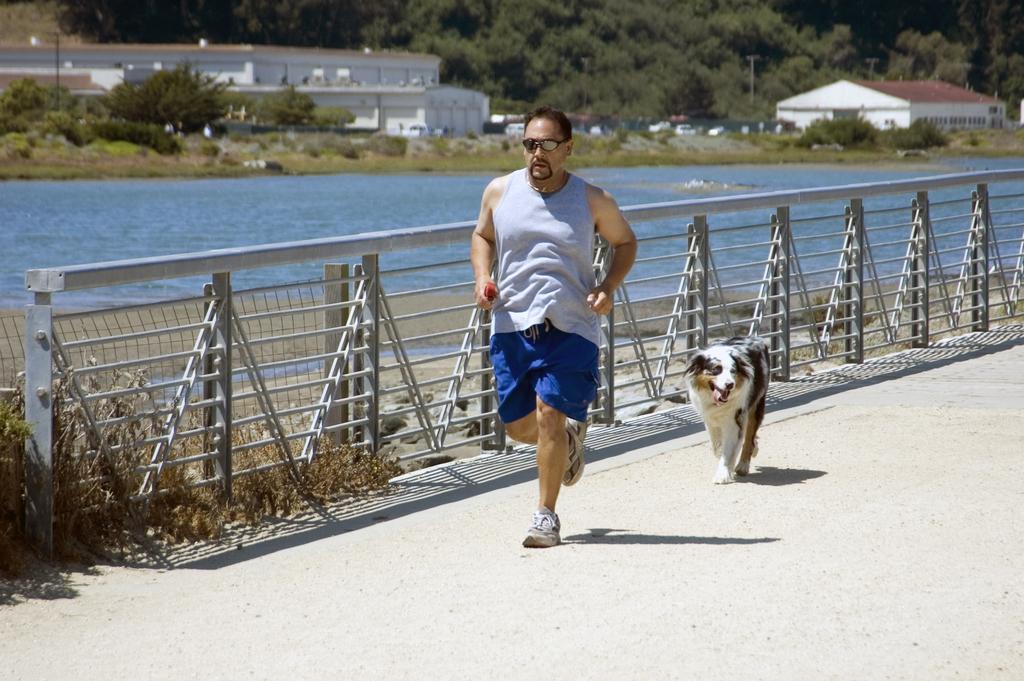Could you give a brief overview of what you see in this image? In the image there is a man running on the ground and behind the man there is a dog, on the left side there is a railing, behind the railing there is a water surface. In the background there are trees and houses. 